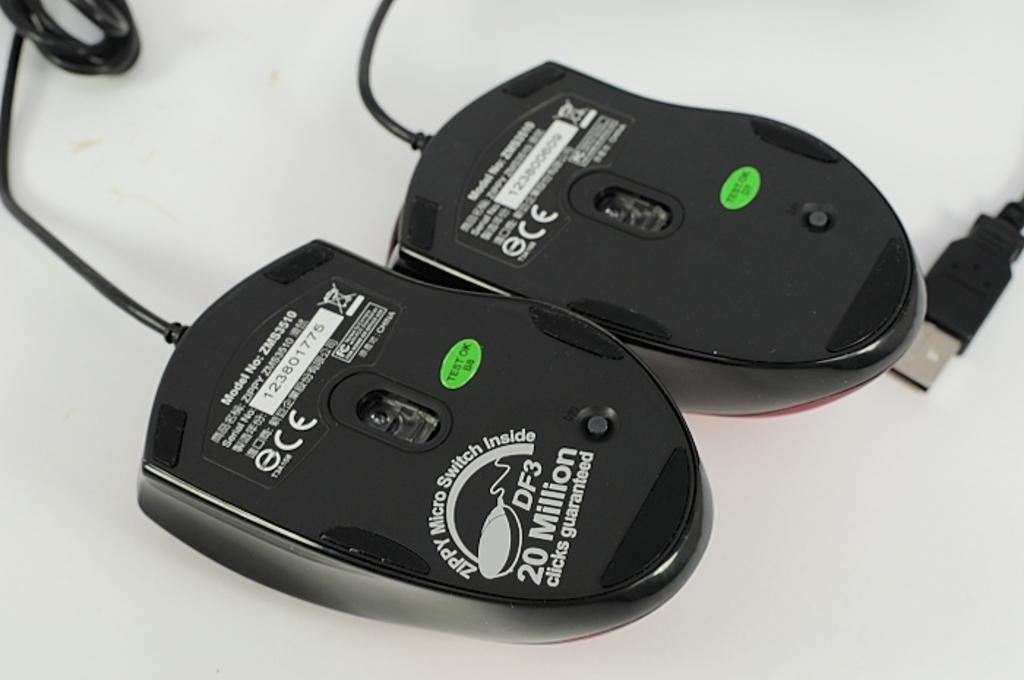<image>
Write a terse but informative summary of the picture. two black computer items and one with 20 on it 